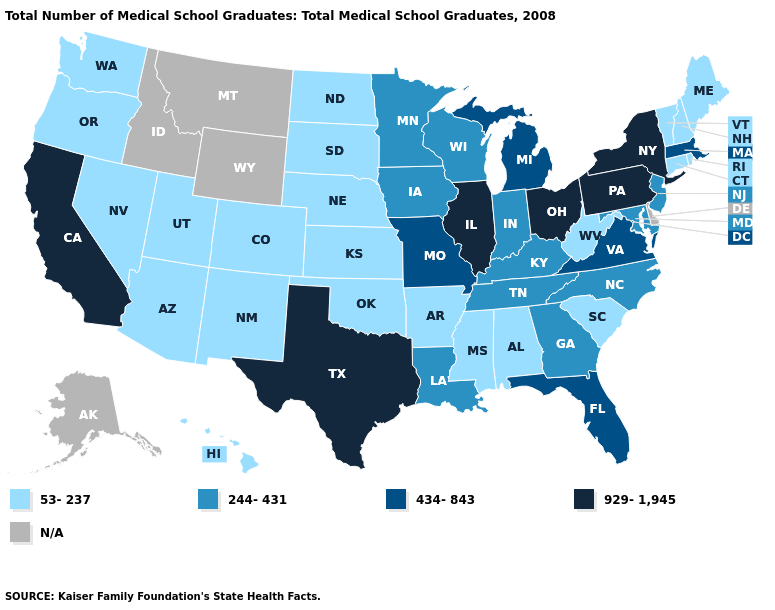Is the legend a continuous bar?
Short answer required. No. Name the states that have a value in the range 929-1,945?
Give a very brief answer. California, Illinois, New York, Ohio, Pennsylvania, Texas. Does the first symbol in the legend represent the smallest category?
Answer briefly. Yes. Does Georgia have the highest value in the South?
Write a very short answer. No. What is the value of Montana?
Keep it brief. N/A. Name the states that have a value in the range 53-237?
Give a very brief answer. Alabama, Arizona, Arkansas, Colorado, Connecticut, Hawaii, Kansas, Maine, Mississippi, Nebraska, Nevada, New Hampshire, New Mexico, North Dakota, Oklahoma, Oregon, Rhode Island, South Carolina, South Dakota, Utah, Vermont, Washington, West Virginia. How many symbols are there in the legend?
Write a very short answer. 5. What is the value of Alaska?
Quick response, please. N/A. Does the map have missing data?
Quick response, please. Yes. What is the value of Virginia?
Concise answer only. 434-843. What is the value of Mississippi?
Answer briefly. 53-237. How many symbols are there in the legend?
Short answer required. 5. Does Colorado have the highest value in the USA?
Quick response, please. No. Name the states that have a value in the range 53-237?
Write a very short answer. Alabama, Arizona, Arkansas, Colorado, Connecticut, Hawaii, Kansas, Maine, Mississippi, Nebraska, Nevada, New Hampshire, New Mexico, North Dakota, Oklahoma, Oregon, Rhode Island, South Carolina, South Dakota, Utah, Vermont, Washington, West Virginia. Among the states that border Delaware , which have the highest value?
Give a very brief answer. Pennsylvania. 